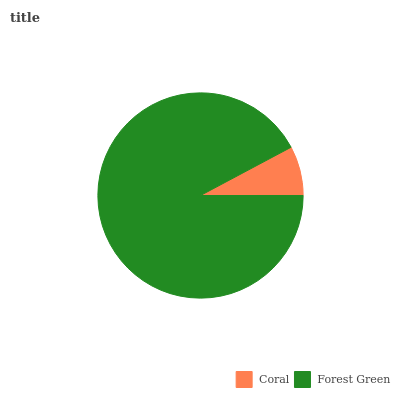Is Coral the minimum?
Answer yes or no. Yes. Is Forest Green the maximum?
Answer yes or no. Yes. Is Forest Green the minimum?
Answer yes or no. No. Is Forest Green greater than Coral?
Answer yes or no. Yes. Is Coral less than Forest Green?
Answer yes or no. Yes. Is Coral greater than Forest Green?
Answer yes or no. No. Is Forest Green less than Coral?
Answer yes or no. No. Is Forest Green the high median?
Answer yes or no. Yes. Is Coral the low median?
Answer yes or no. Yes. Is Coral the high median?
Answer yes or no. No. Is Forest Green the low median?
Answer yes or no. No. 